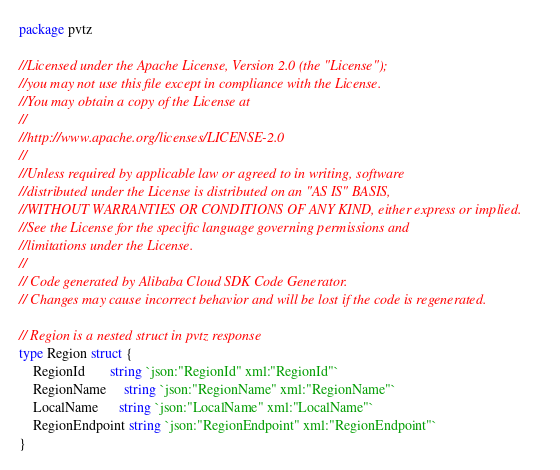<code> <loc_0><loc_0><loc_500><loc_500><_Go_>package pvtz

//Licensed under the Apache License, Version 2.0 (the "License");
//you may not use this file except in compliance with the License.
//You may obtain a copy of the License at
//
//http://www.apache.org/licenses/LICENSE-2.0
//
//Unless required by applicable law or agreed to in writing, software
//distributed under the License is distributed on an "AS IS" BASIS,
//WITHOUT WARRANTIES OR CONDITIONS OF ANY KIND, either express or implied.
//See the License for the specific language governing permissions and
//limitations under the License.
//
// Code generated by Alibaba Cloud SDK Code Generator.
// Changes may cause incorrect behavior and will be lost if the code is regenerated.

// Region is a nested struct in pvtz response
type Region struct {
	RegionId       string `json:"RegionId" xml:"RegionId"`
	RegionName     string `json:"RegionName" xml:"RegionName"`
	LocalName      string `json:"LocalName" xml:"LocalName"`
	RegionEndpoint string `json:"RegionEndpoint" xml:"RegionEndpoint"`
}
</code> 